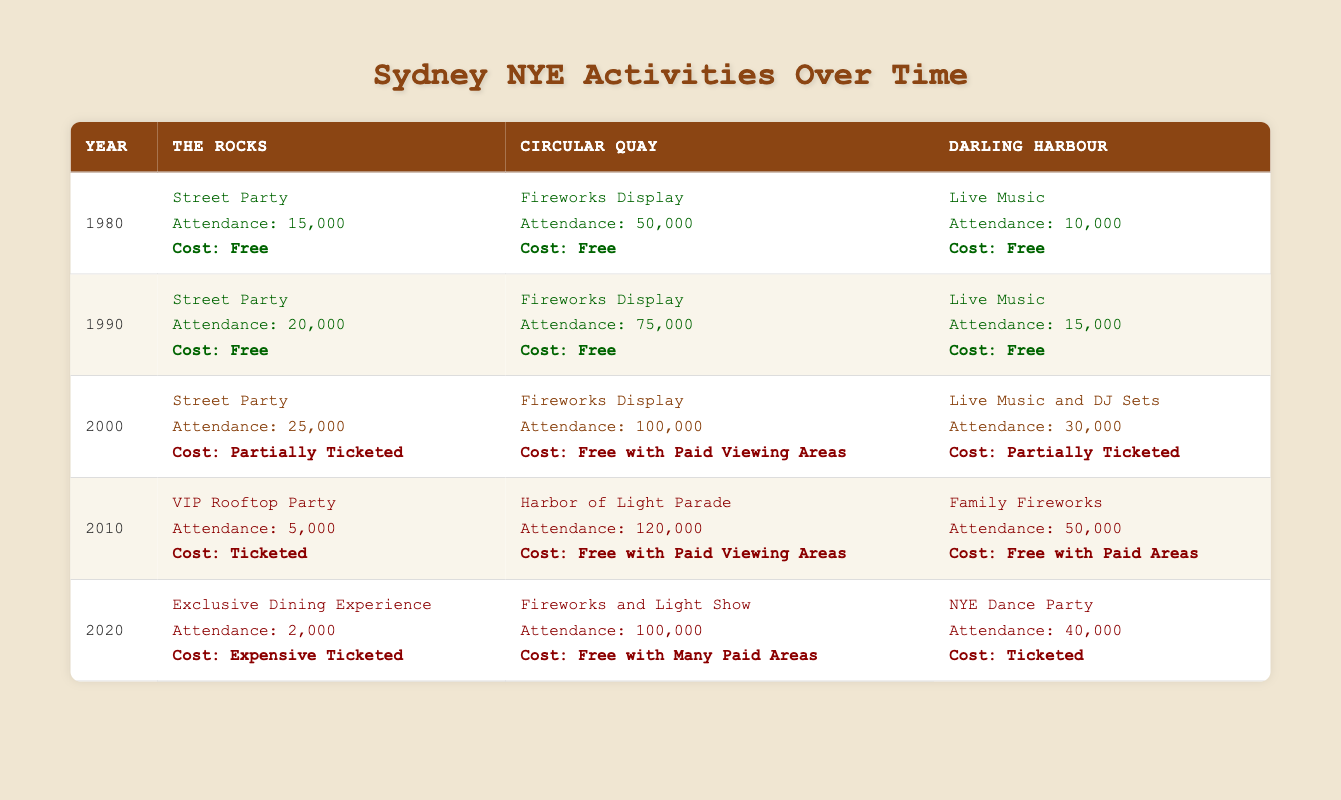What specific activities were offered in Circular Quay in the year 1980? In the table, under the year 1980, the activities listed for Circular Quay are "Fireworks Display" with an attendance of 50,000 and a cost of "Free."
Answer: Fireworks Display What was the attendance at the Darling Harbour activity in 1990? Referring to the year 1990 in the table, the activity in Darling Harbour was "Live Music," and the attendance was recorded as 15,000.
Answer: 15,000 How did the cost structure of activities change from traditional to modern in The Rocks from 1980 to 2020? In The Rocks, the activities in 1980 were "Street Party" (Free), in 1990 it was again "Street Party" (Free), in 2000 it changed to "Street Party" (Partially Ticketed), in 2010 it was a "VIP Rooftop Party" (Ticketed), and in 2020 it was an "Exclusive Dining Experience" (Expensive Ticketed). This shows a progression from entirely free to expensive ticketed events.
Answer: Cost increased from Free to Expensive Ticketed What was the average attendance for Modern activities in the table? The modern activities listed are: 5,000 (2010), 100,000 (2020 at Circular Quay), and 40,000 (2020 at Darling Harbour). Adding these yields 5,000 + 100,000 + 40,000 = 145,000. There are 3 data points, so the average attendance is 145,000 / 3 = 48,333.
Answer: 48,333 Was there a year in which the attendance for the Circular Quay activity was greater than 100,000? Yes, in the year 2000, the activity "Fireworks Display" had an attendance of 100,000.
Answer: Yes How much did the attendance increase at The Rocks from 1990 to 2010? In 1990, The Rocks had an attendance of 20,000 for the "Street Party." In 2010, it had an attendance of 5,000 for the "VIP Rooftop Party." The difference is 20,000 - 5,000 = 15,000.
Answer: Decrease of 15,000 What is the most attended activity in Circular Quay throughout the years presented? From the various years, the attendance figures for Circular Quay are: 50,000 (1980), 75,000 (1990), 100,000 (2000), 120,000 (2010), and 100,000 (2020). The highest among these is 120,000 in 2010 for the "Harbor of Light Parade."
Answer: Harbor of Light Parade with 120,000 attendees What percentage of activities in Darling Harbour were ticketed by 2020? Activities listed for Darling Harbour are: 10,000 (1980 - Free), 15,000 (1990 - Free), 30,000 (2000 - Partially Ticketed), 50,000 (2010 - Free with Paid Areas), and 40,000 (2020 - Ticketed). Out of the 5 total entries, 1 is ticketed (2020), so the percentage is (1/5) * 100 = 20%.
Answer: 20% 